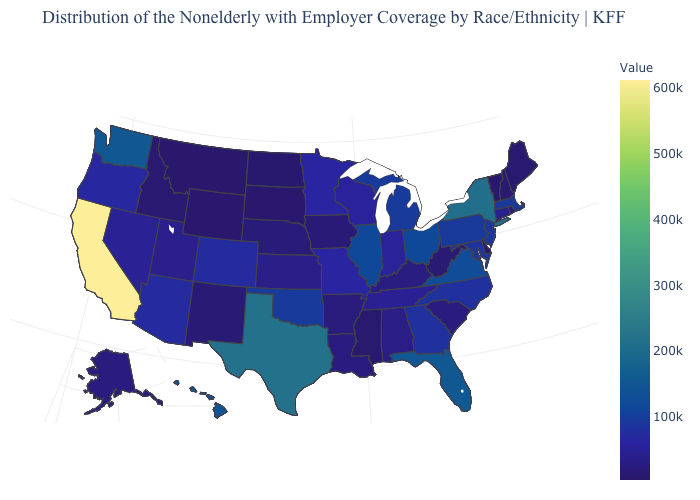Among the states that border Florida , does Georgia have the highest value?
Concise answer only. Yes. Which states have the highest value in the USA?
Short answer required. California. Does Vermont have the highest value in the USA?
Be succinct. No. Which states have the lowest value in the USA?
Write a very short answer. Vermont. Among the states that border Missouri , which have the highest value?
Short answer required. Illinois. 